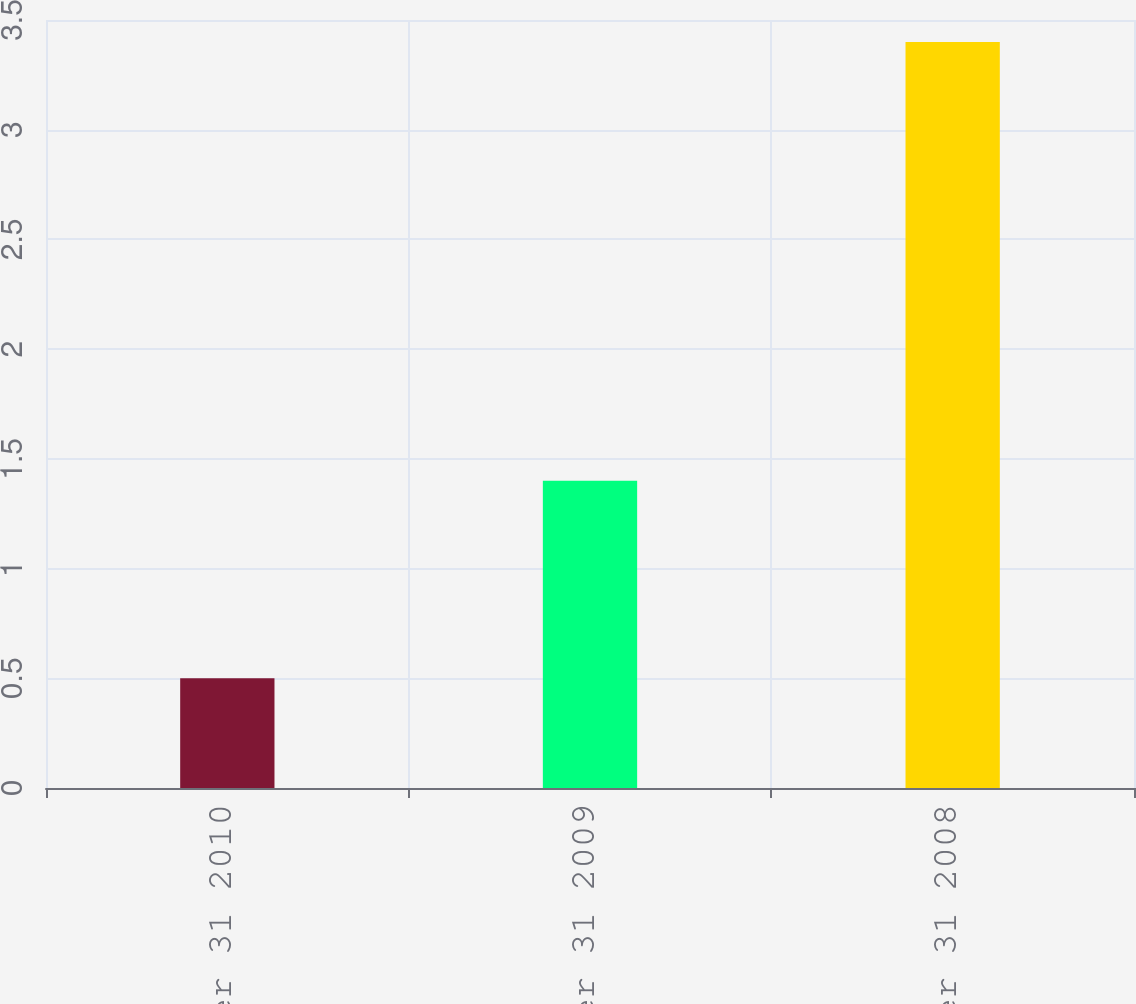Convert chart. <chart><loc_0><loc_0><loc_500><loc_500><bar_chart><fcel>December 31 2010<fcel>December 31 2009<fcel>December 31 2008<nl><fcel>0.5<fcel>1.4<fcel>3.4<nl></chart> 